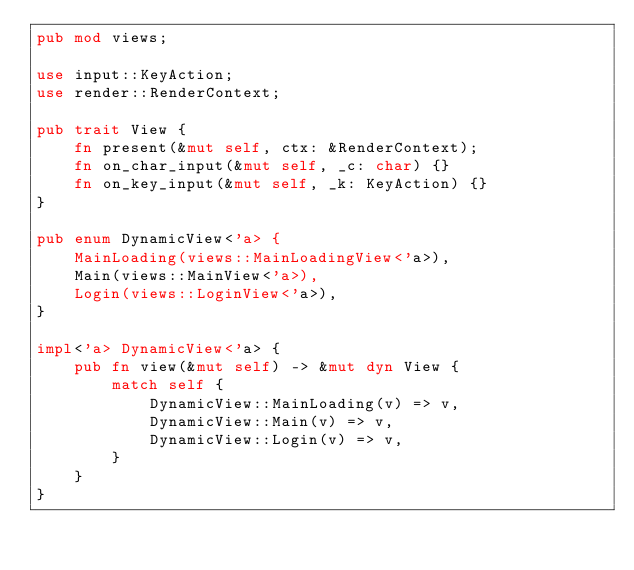Convert code to text. <code><loc_0><loc_0><loc_500><loc_500><_Rust_>pub mod views;

use input::KeyAction;
use render::RenderContext;

pub trait View {
    fn present(&mut self, ctx: &RenderContext);
    fn on_char_input(&mut self, _c: char) {}
    fn on_key_input(&mut self, _k: KeyAction) {}
}

pub enum DynamicView<'a> {
    MainLoading(views::MainLoadingView<'a>),
    Main(views::MainView<'a>),
    Login(views::LoginView<'a>),
}

impl<'a> DynamicView<'a> {
    pub fn view(&mut self) -> &mut dyn View {
        match self {
            DynamicView::MainLoading(v) => v,
            DynamicView::Main(v) => v,
            DynamicView::Login(v) => v,
        }
    }
}
</code> 